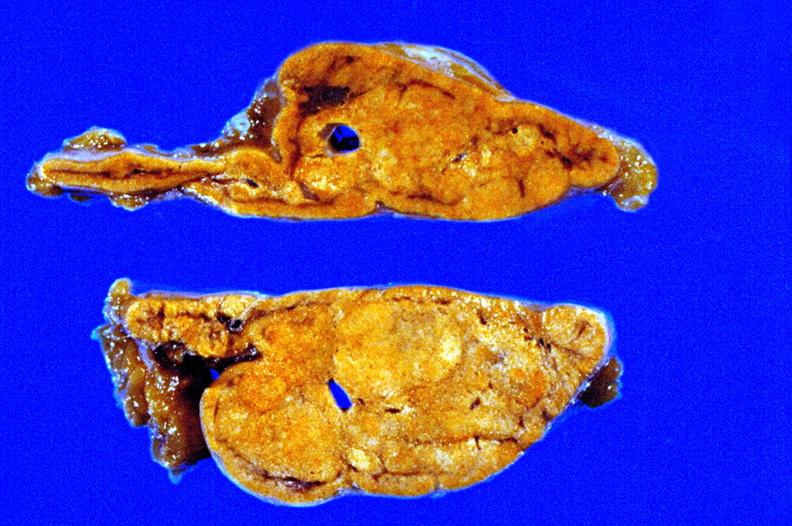what does this image show?
Answer the question using a single word or phrase. Fixed tissue cut surface close-up view rather good apparently non-functional 